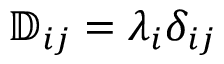<formula> <loc_0><loc_0><loc_500><loc_500>\mathbb { D } _ { i j } = \lambda _ { i } \delta _ { i j }</formula> 